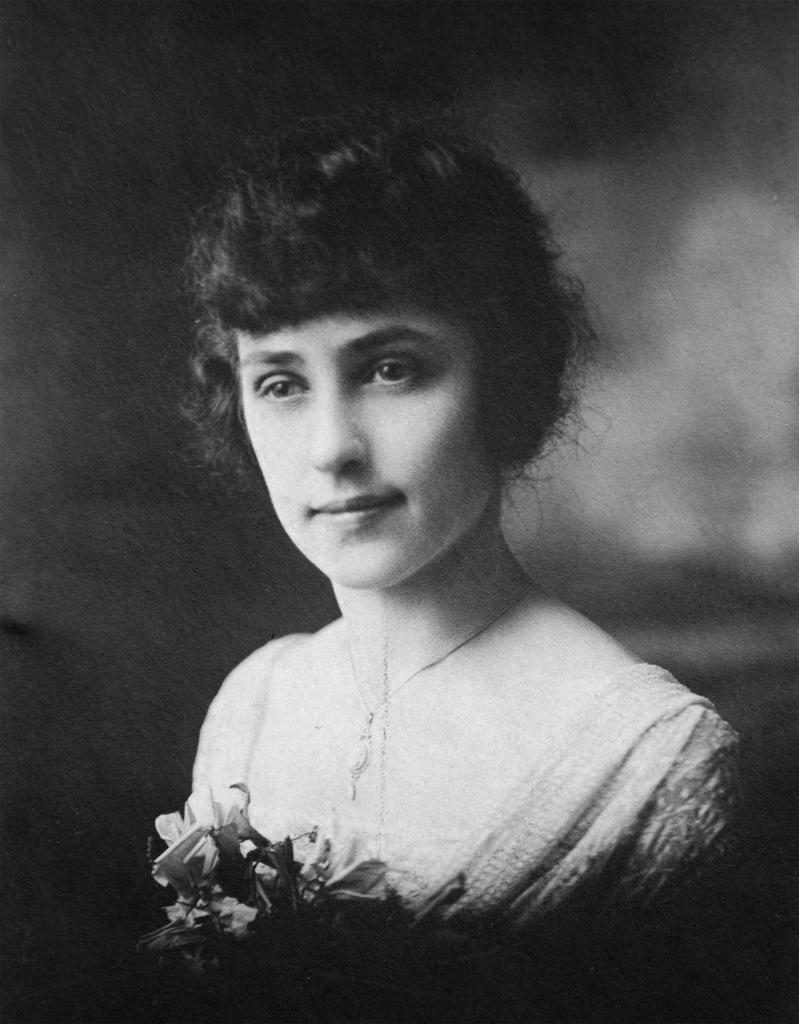What is the color scheme of the image? The image is black and white. Can you describe the person in the image? There is a person in the image. What is the person holding in the image? The person is holding a bouquet. Where is the mountain located in the image? There is no mountain present in the image. What type of slip is the person wearing in the image? There is no information about the person's clothing in the image, and no slip is visible. 